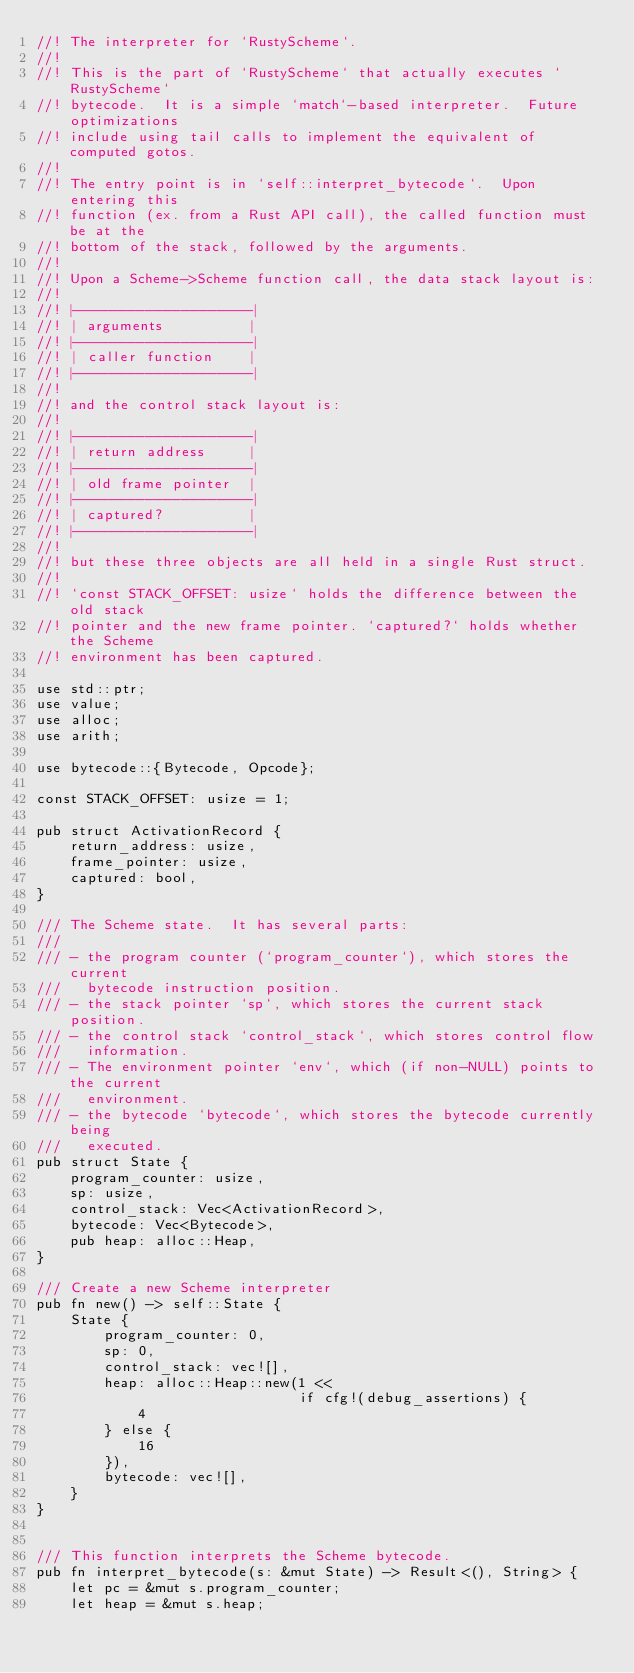<code> <loc_0><loc_0><loc_500><loc_500><_Rust_>//! The interpreter for `RustyScheme`.
//!
//! This is the part of `RustyScheme` that actually executes `RustyScheme`
//! bytecode.  It is a simple `match`-based interpreter.  Future optimizations
//! include using tail calls to implement the equivalent of computed gotos.
//!
//! The entry point is in `self::interpret_bytecode`.  Upon entering this
//! function (ex. from a Rust API call), the called function must be at the
//! bottom of the stack, followed by the arguments.
//!
//! Upon a Scheme->Scheme function call, the data stack layout is:
//!
//! |--------------------|
//! | arguments          |
//! |--------------------|
//! | caller function    |
//! |--------------------|
//!
//! and the control stack layout is:
//!
//! |--------------------|
//! | return address     |
//! |--------------------|
//! | old frame pointer  |
//! |--------------------|
//! | captured?          |
//! |--------------------|
//!
//! but these three objects are all held in a single Rust struct.
//!
//! `const STACK_OFFSET: usize` holds the difference between the old stack
//! pointer and the new frame pointer. `captured?` holds whether the Scheme
//! environment has been captured.

use std::ptr;
use value;
use alloc;
use arith;

use bytecode::{Bytecode, Opcode};

const STACK_OFFSET: usize = 1;

pub struct ActivationRecord {
    return_address: usize,
    frame_pointer: usize,
    captured: bool,
}

/// The Scheme state.  It has several parts:
///
/// - the program counter (`program_counter`), which stores the current
///   bytecode instruction position.
/// - the stack pointer `sp`, which stores the current stack position.
/// - the control stack `control_stack`, which stores control flow
///   information.
/// - The environment pointer `env`, which (if non-NULL) points to the current
///   environment.
/// - the bytecode `bytecode`, which stores the bytecode currently being
///   executed.
pub struct State {
    program_counter: usize,
    sp: usize,
    control_stack: Vec<ActivationRecord>,
    bytecode: Vec<Bytecode>,
    pub heap: alloc::Heap,
}

/// Create a new Scheme interpreter
pub fn new() -> self::State {
    State {
        program_counter: 0,
        sp: 0,
        control_stack: vec![],
        heap: alloc::Heap::new(1 <<
                               if cfg!(debug_assertions) {
            4
        } else {
            16
        }),
        bytecode: vec![],
    }
}


/// This function interprets the Scheme bytecode.
pub fn interpret_bytecode(s: &mut State) -> Result<(), String> {
    let pc = &mut s.program_counter;
    let heap = &mut s.heap;</code> 